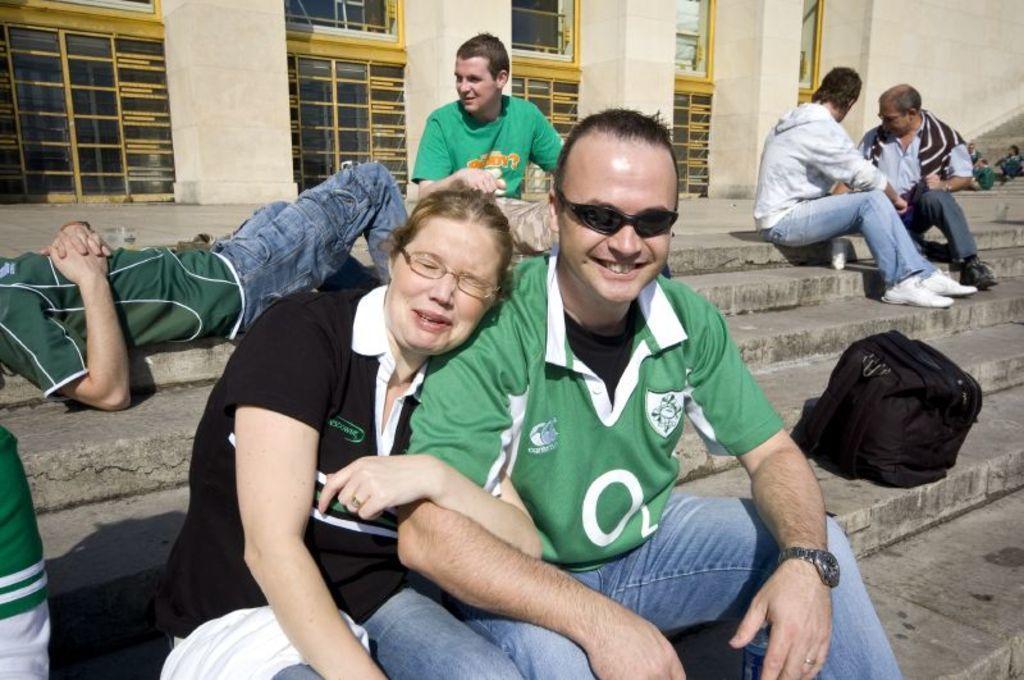Could you give a brief overview of what you see in this image? In this image I can see some people are sitting. On the left side I can see a person lying. In the background, I can see the windows. 